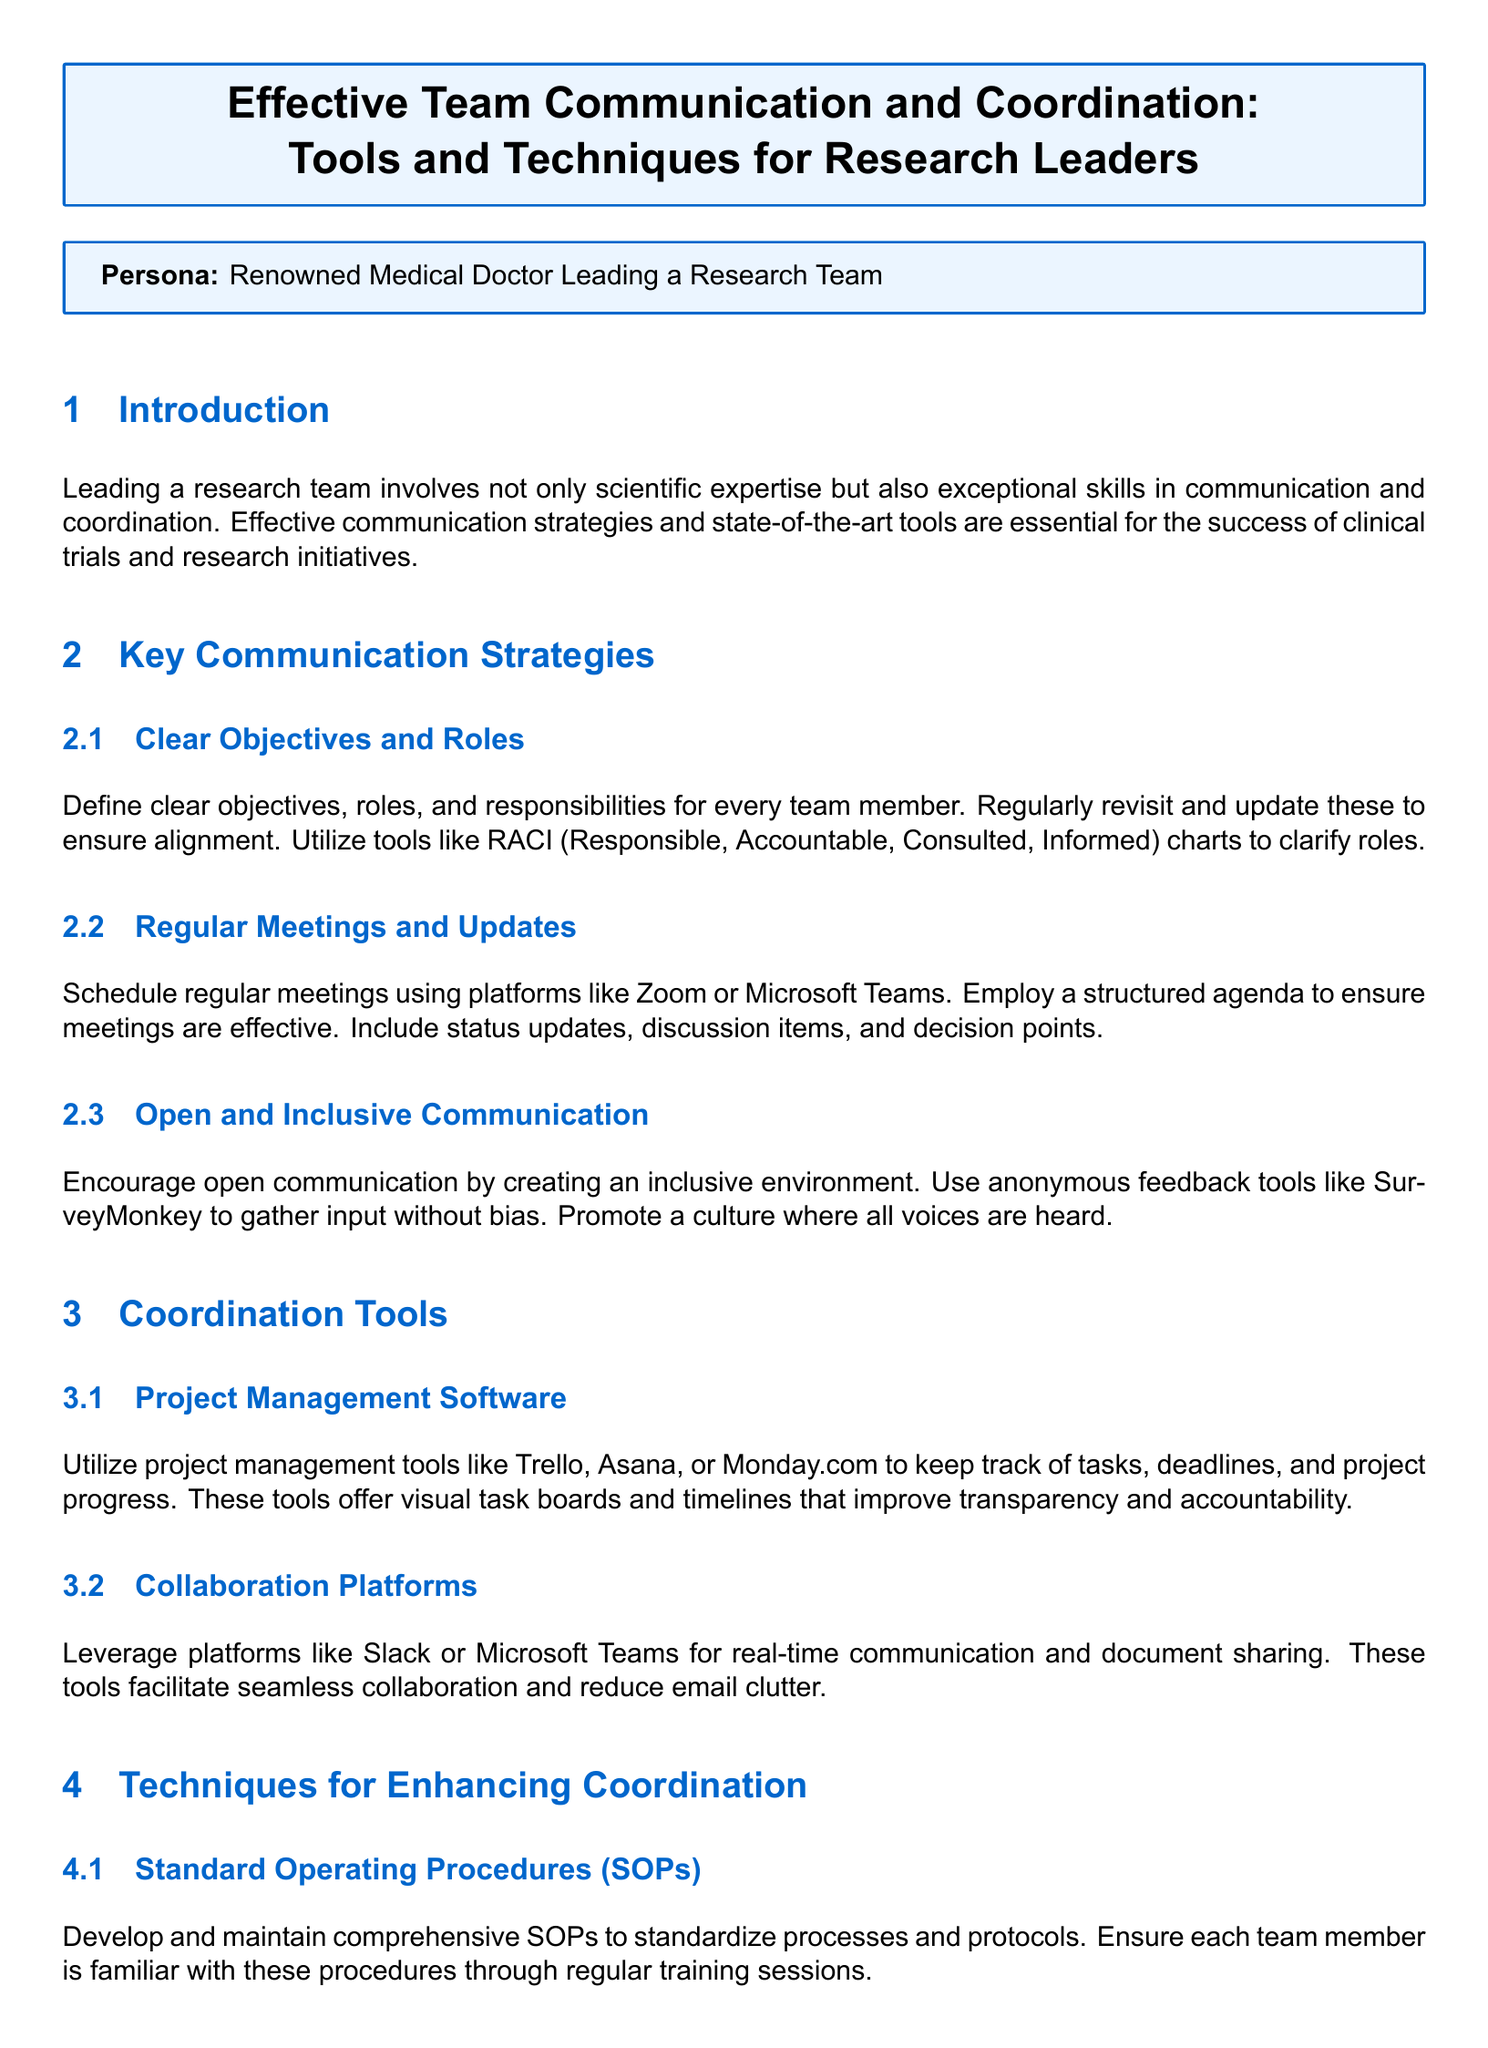What are the key areas addressed in the document? The document focuses on effective team communication and coordination, highlighting tools and techniques for research leaders.
Answer: Communication and coordination What platforms are suggested for regular meetings? Zoom and Microsoft Teams are mentioned as platforms for scheduling regular meetings with structured agendas.
Answer: Zoom or Microsoft Teams What does RACI stand for? RACI is an acronym for Responsible, Accountable, Consulted, Informed, utilized to clarify roles within the team.
Answer: Responsible, Accountable, Consulted, Informed Which project management tools are recommended? Trello, Asana, and Monday.com are listed as project management tools to track tasks and deadlines.
Answer: Trello, Asana, Monday.com What kind of procedures should be developed to enhance coordination? Standard Operating Procedures (SOPs) are recommended to standardize processes and ensure familiarity among team members.
Answer: Standard Operating Procedures What feedback tools are mentioned for gathering input? SurveyMonkey is mentioned as an anonymous feedback tool to promote open communication.
Answer: SurveyMonkey How can integrated data systems benefit clinical trials? Integrated data systems like REDCap or OpenClinica support data consistency and facilitate easier monitoring and reporting.
Answer: Data consistency What is the primary objective of effective communication strategies outlined in the document? The primary objective is to ensure clarity in objectives, roles, and responsibilities for team members.
Answer: Clarity in objectives How often should meetings occur according to the document? Regular meetings should be scheduled, though the document does not specify an exact frequency.
Answer: Regularly 